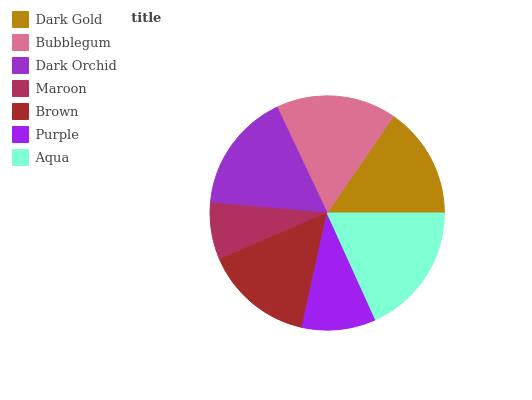Is Maroon the minimum?
Answer yes or no. Yes. Is Aqua the maximum?
Answer yes or no. Yes. Is Bubblegum the minimum?
Answer yes or no. No. Is Bubblegum the maximum?
Answer yes or no. No. Is Bubblegum greater than Dark Gold?
Answer yes or no. Yes. Is Dark Gold less than Bubblegum?
Answer yes or no. Yes. Is Dark Gold greater than Bubblegum?
Answer yes or no. No. Is Bubblegum less than Dark Gold?
Answer yes or no. No. Is Dark Gold the high median?
Answer yes or no. Yes. Is Dark Gold the low median?
Answer yes or no. Yes. Is Purple the high median?
Answer yes or no. No. Is Maroon the low median?
Answer yes or no. No. 